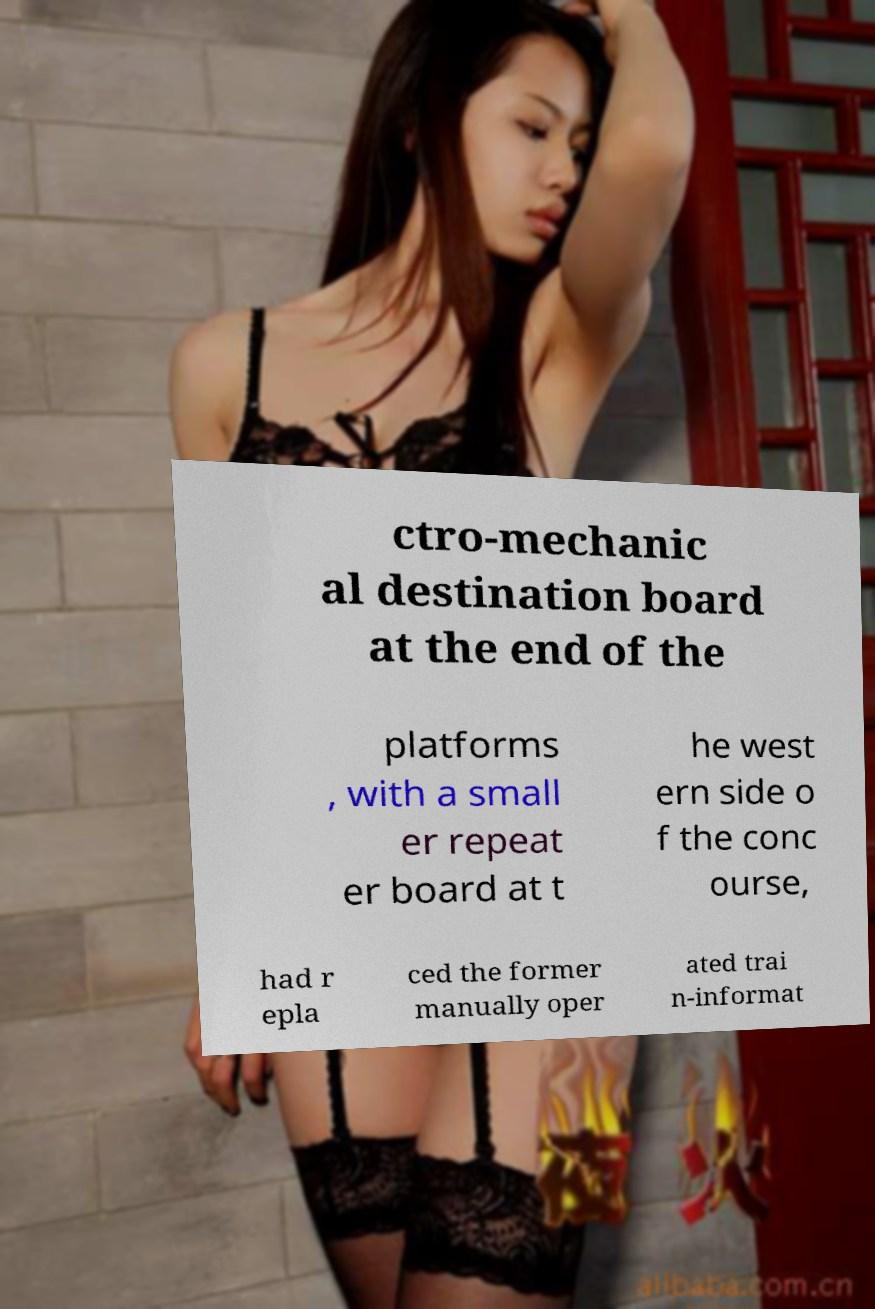I need the written content from this picture converted into text. Can you do that? ctro-mechanic al destination board at the end of the platforms , with a small er repeat er board at t he west ern side o f the conc ourse, had r epla ced the former manually oper ated trai n-informat 